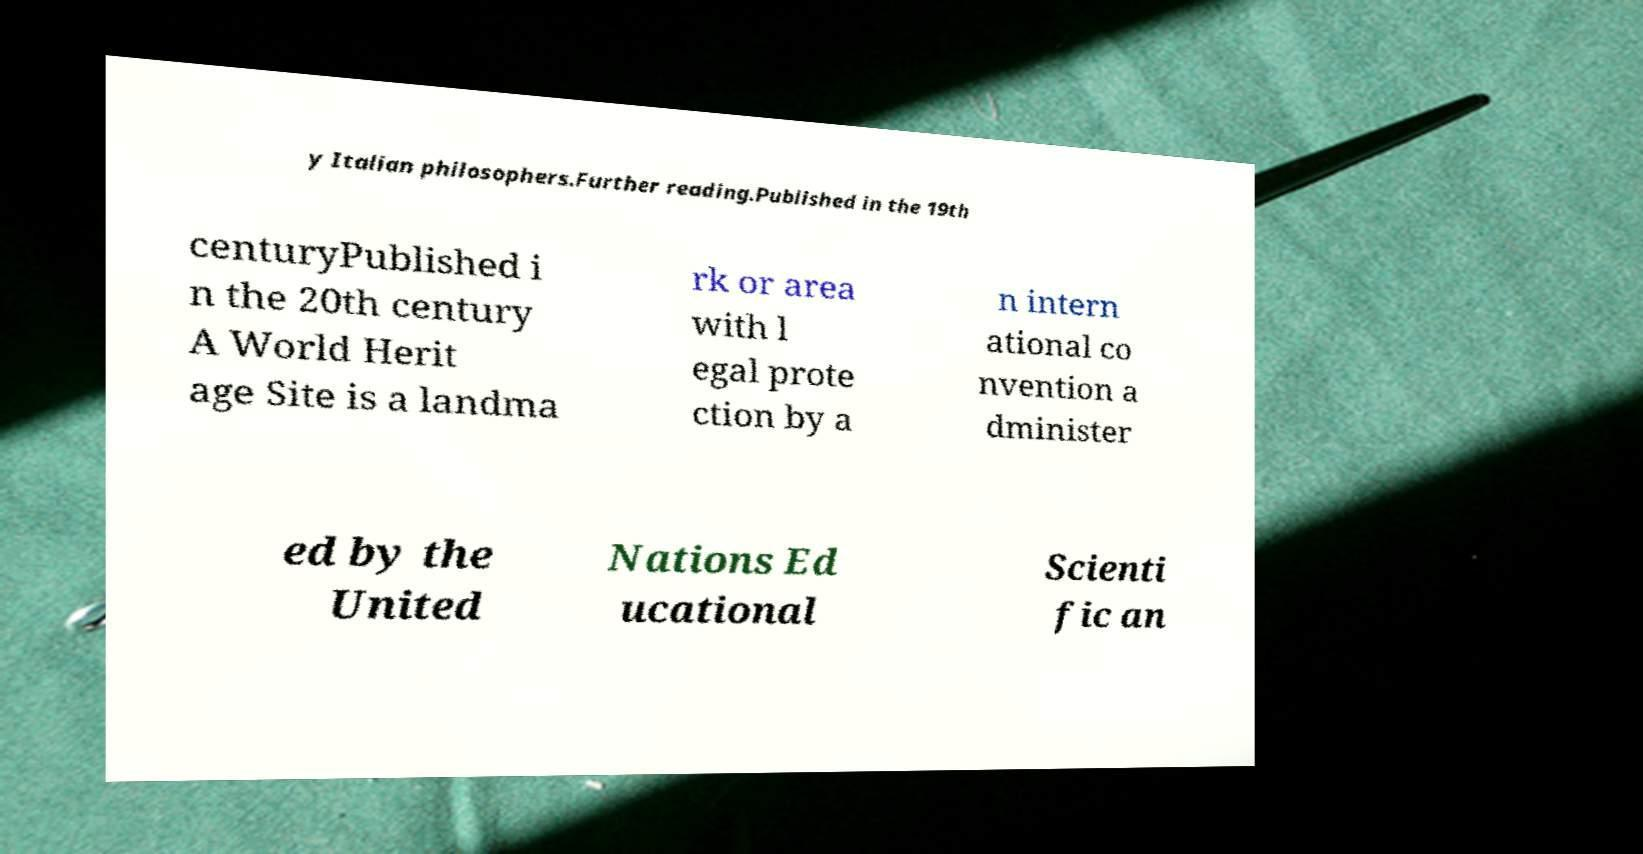Can you accurately transcribe the text from the provided image for me? y Italian philosophers.Further reading.Published in the 19th centuryPublished i n the 20th century A World Herit age Site is a landma rk or area with l egal prote ction by a n intern ational co nvention a dminister ed by the United Nations Ed ucational Scienti fic an 